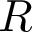<formula> <loc_0><loc_0><loc_500><loc_500>R</formula> 